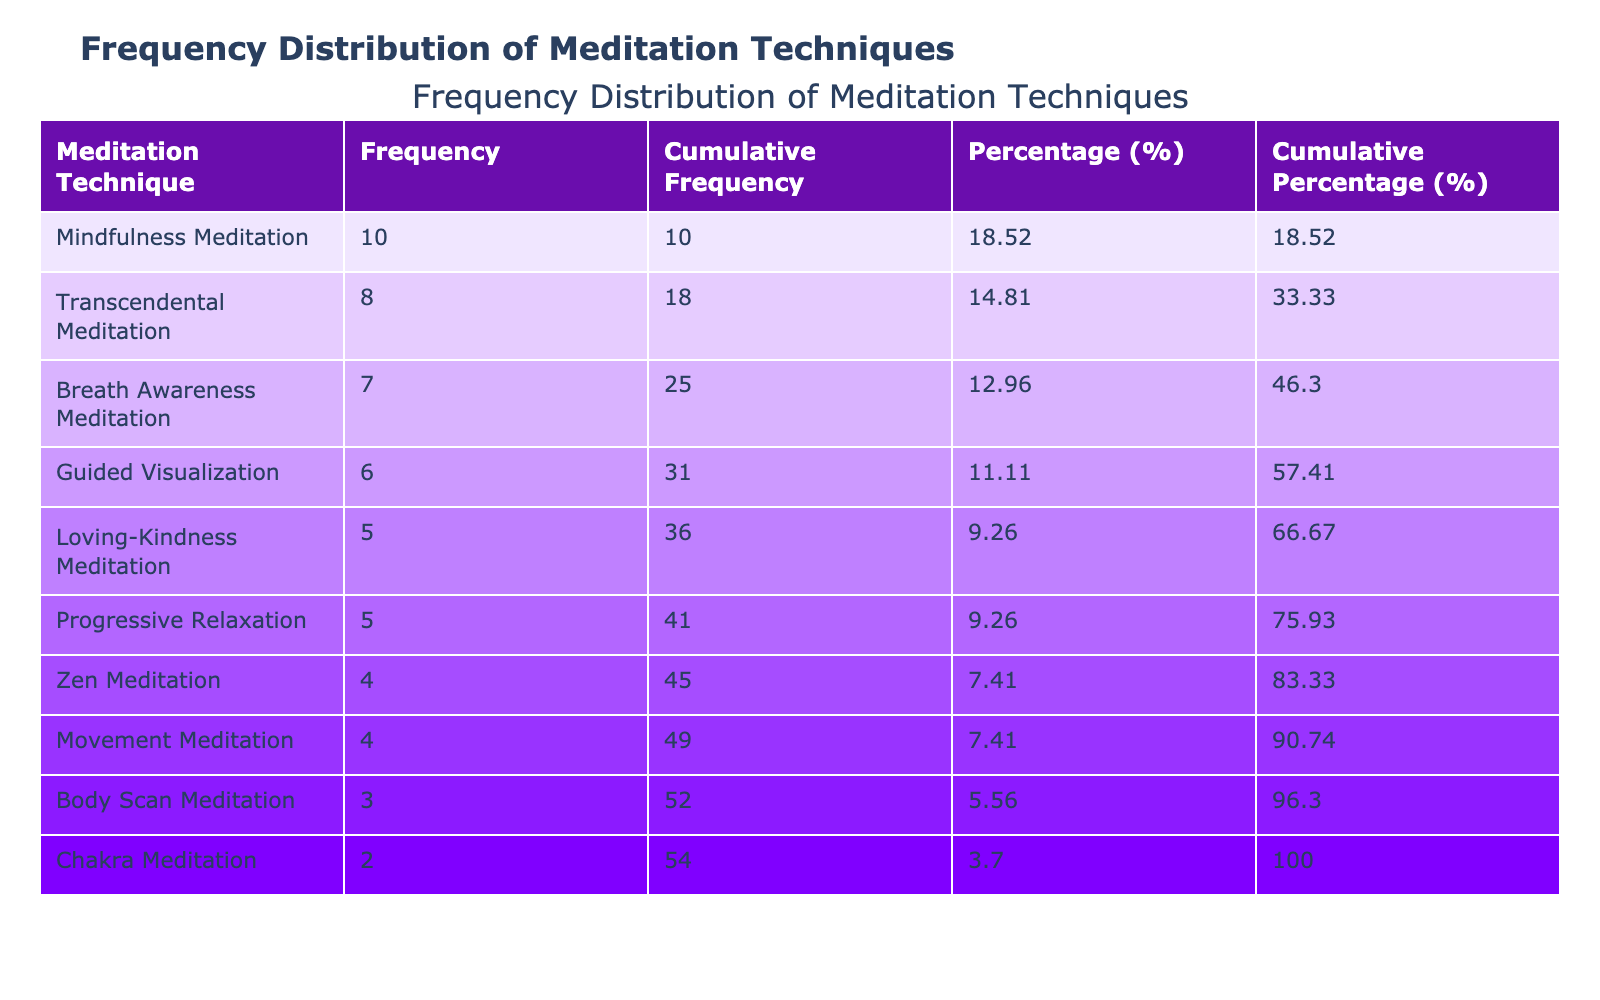What is the frequency of Mindfulness Meditation? The table lists the frequency for each meditation technique. Mindfulness Meditation has a frequency of 10.
Answer: 10 Which meditation technique has the highest frequency? By examining the frequencies, Mindfulness Meditation has the highest count at 10 compared to others.
Answer: Mindfulness Meditation What is the cumulative frequency of Breath Awareness Meditation? The table shows that Breath Awareness Meditation has a frequency of 7. The cumulative frequency includes all frequencies up to this point, so it sums the frequencies of all techniques listed before it (10 + 8 + 6 + 5 + 4 + 3 + 2) = 38, plus its own 7, totaling 45.
Answer: 45 How many techniques have a frequency greater than 5? Looking at the table, there are five techniques with frequencies greater than 5: Mindfulness Meditation (10), Transcendental Meditation (8), Breath Awareness Meditation (7), Guided Visualization (6), and Loving-Kindness Meditation (5).
Answer: 5 What percentage of all practiced meditations does Body Scan Meditation represent? To calculate the percentage for Body Scan Meditation, identify its frequency of 3. The total frequency is 10 + 8 + 6 + 5 + 4 + 3 + 2 + 7 + 4 + 5 = 60. The percentage is (3/60) * 100 = 5.00%.
Answer: 5.00% Is the total frequency of Loving-Kindness Meditation greater than Zen Meditation? The frequency of Loving-Kindness Meditation is 5, while Zen Meditation has a frequency of 4. Therefore, Loving-Kindness Meditation is greater than Zen Meditation.
Answer: Yes What is the average frequency of all meditation techniques? To find the average frequency, sum all the techniques' frequencies (60) and divide by the number of techniques (10). 60/10 = 6.
Answer: 6 Which meditation technique has a cumulative percentage closest to 50%? First, calculate the cumulative percentages from the table data. Mindfulness Meditation has a cumulative percentage of 16.67%, Transcendental Meditation brings it to 30.00%, Guided Visualization to 40.00%, and Breath Awareness Meditation to 50.00%. Therefore, Breath Awareness Meditation is closest to 50%.
Answer: Breath Awareness Meditation Which technique ranks second in terms of frequency and what is its cumulative frequency? The second-ranking technique in frequency is Transcendental Meditation with a frequency of 8. Its cumulative frequency, calculated from summing prior frequencies (10 + 8) = 18.
Answer: Transcendental Meditation, 18 